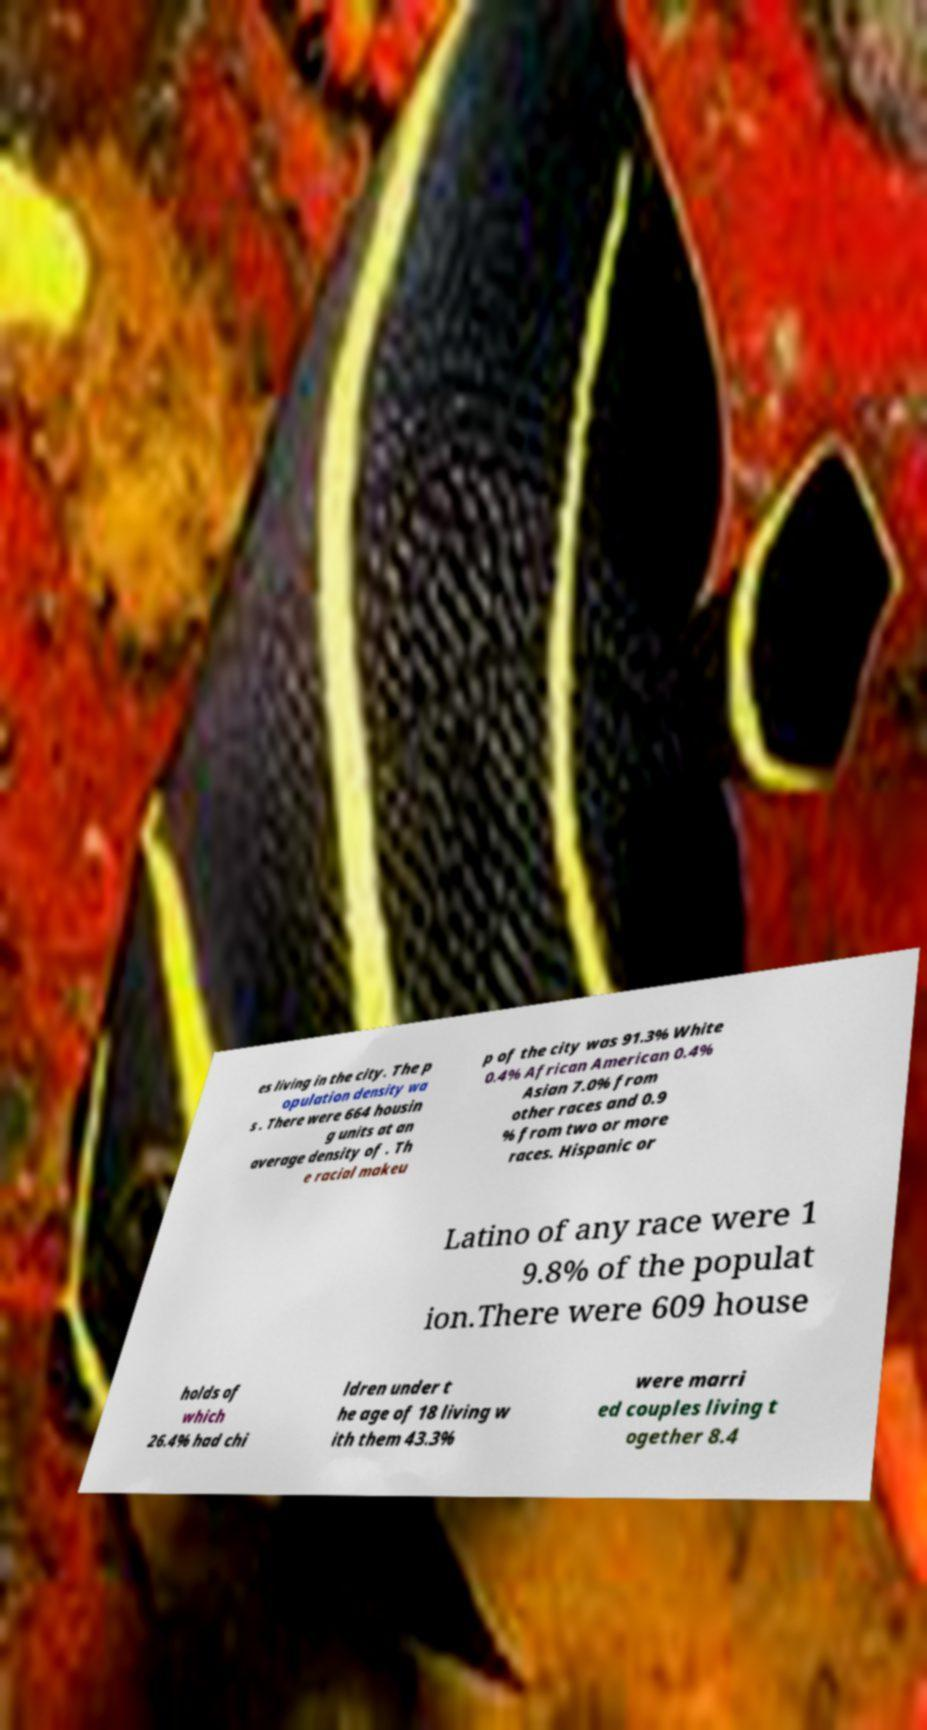Could you assist in decoding the text presented in this image and type it out clearly? es living in the city. The p opulation density wa s . There were 664 housin g units at an average density of . Th e racial makeu p of the city was 91.3% White 0.4% African American 0.4% Asian 7.0% from other races and 0.9 % from two or more races. Hispanic or Latino of any race were 1 9.8% of the populat ion.There were 609 house holds of which 26.4% had chi ldren under t he age of 18 living w ith them 43.3% were marri ed couples living t ogether 8.4 